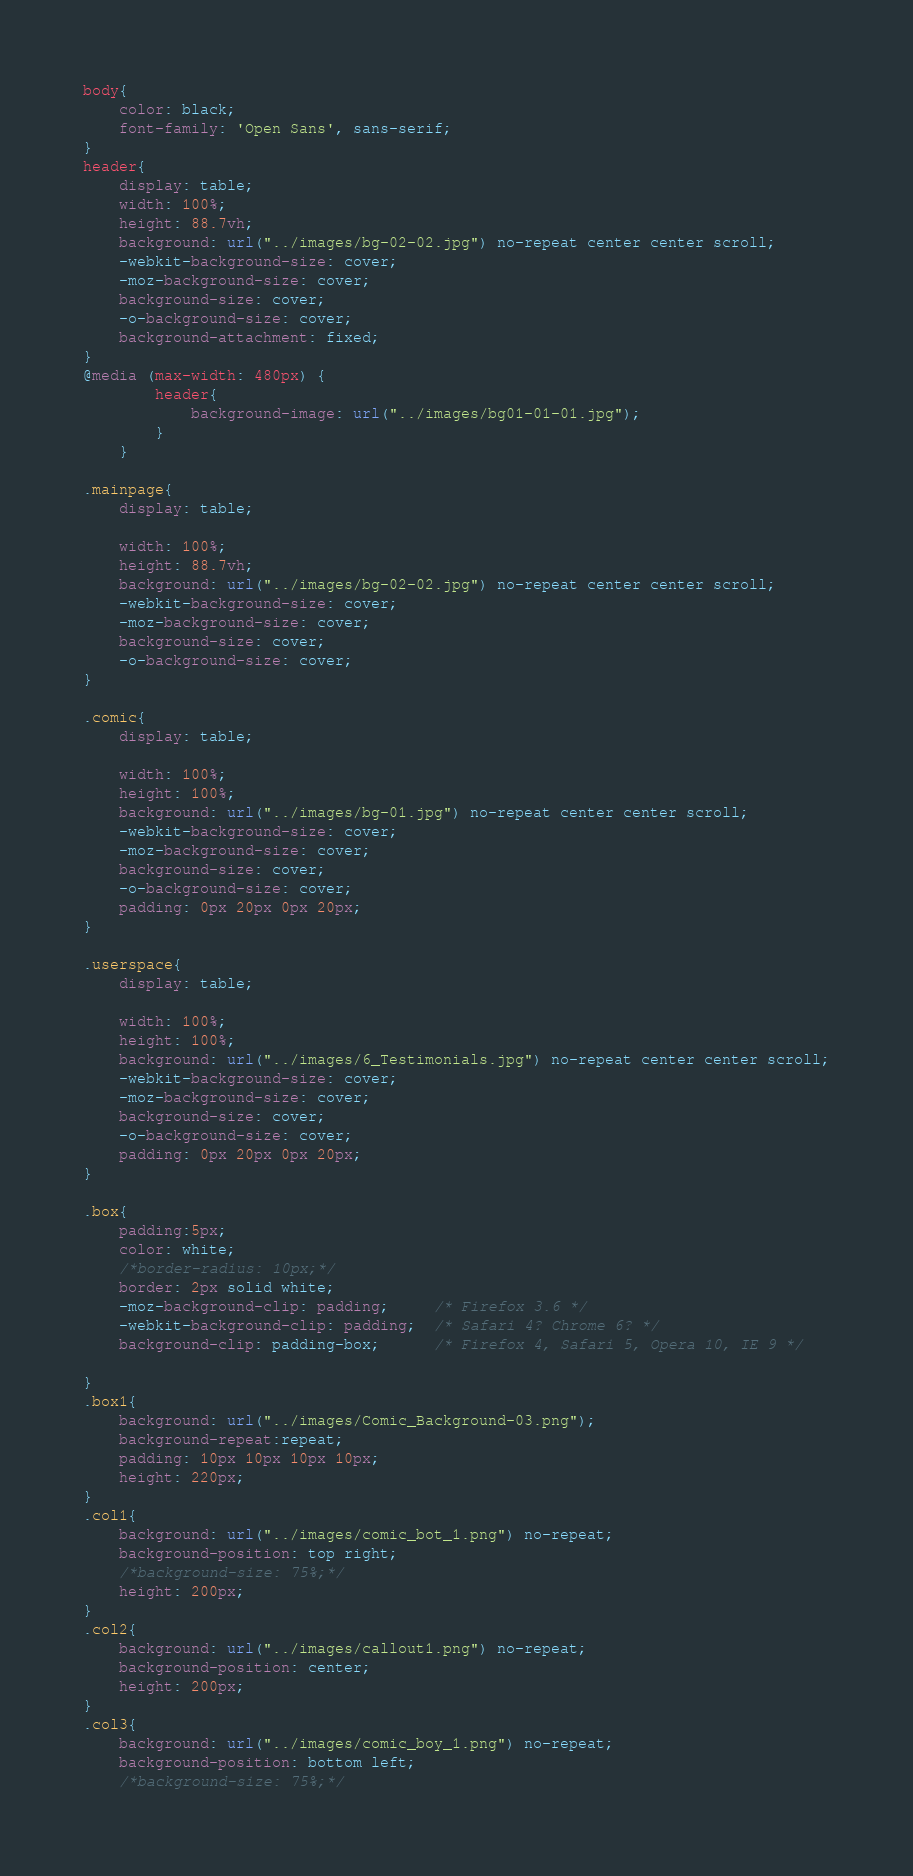Convert code to text. <code><loc_0><loc_0><loc_500><loc_500><_CSS_>body{
    color: black;
    font-family: 'Open Sans', sans-serif;
}
header{
    display: table;
    width: 100%;
    height: 88.7vh;
    background: url("../images/bg-02-02.jpg") no-repeat center center scroll;
    -webkit-background-size: cover;
    -moz-background-size: cover;
    background-size: cover;
    -o-background-size: cover;
    background-attachment: fixed;
}
@media (max-width: 480px) {
        header{
            background-image: url("../images/bg01-01-01.jpg");
        }
    }

.mainpage{
    display: table;

    width: 100%;
    height: 88.7vh;
    background: url("../images/bg-02-02.jpg") no-repeat center center scroll;
    -webkit-background-size: cover;
    -moz-background-size: cover;
    background-size: cover;
    -o-background-size: cover;
}

.comic{
    display: table;

    width: 100%;
    height: 100%;
    background: url("../images/bg-01.jpg") no-repeat center center scroll;
    -webkit-background-size: cover;
    -moz-background-size: cover;
    background-size: cover;
    -o-background-size: cover;
    padding: 0px 20px 0px 20px;
}

.userspace{
    display: table;

    width: 100%;
    height: 100%;
    background: url("../images/6_Testimonials.jpg") no-repeat center center scroll;
    -webkit-background-size: cover;
    -moz-background-size: cover;
    background-size: cover;
    -o-background-size: cover;
    padding: 0px 20px 0px 20px;
}

.box{
    padding:5px;
    color: white;
    /*border-radius: 10px;*/
    border: 2px solid white;             
    -moz-background-clip: padding;     /* Firefox 3.6 */
    -webkit-background-clip: padding;  /* Safari 4? Chrome 6? */
    background-clip: padding-box;      /* Firefox 4, Safari 5, Opera 10, IE 9 */
                    
}
.box1{
    background: url("../images/Comic_Background-03.png");
    background-repeat:repeat;
    padding: 10px 10px 10px 10px;
    height: 220px;
}
.col1{
    background: url("../images/comic_bot_1.png") no-repeat;
    background-position: top right;
    /*background-size: 75%;*/
    height: 200px; 
}
.col2{
    background: url("../images/callout1.png") no-repeat;  
    background-position: center;
    height: 200px;
}
.col3{
    background: url("../images/comic_boy_1.png") no-repeat;
    background-position: bottom left;
    /*background-size: 75%;*/</code> 